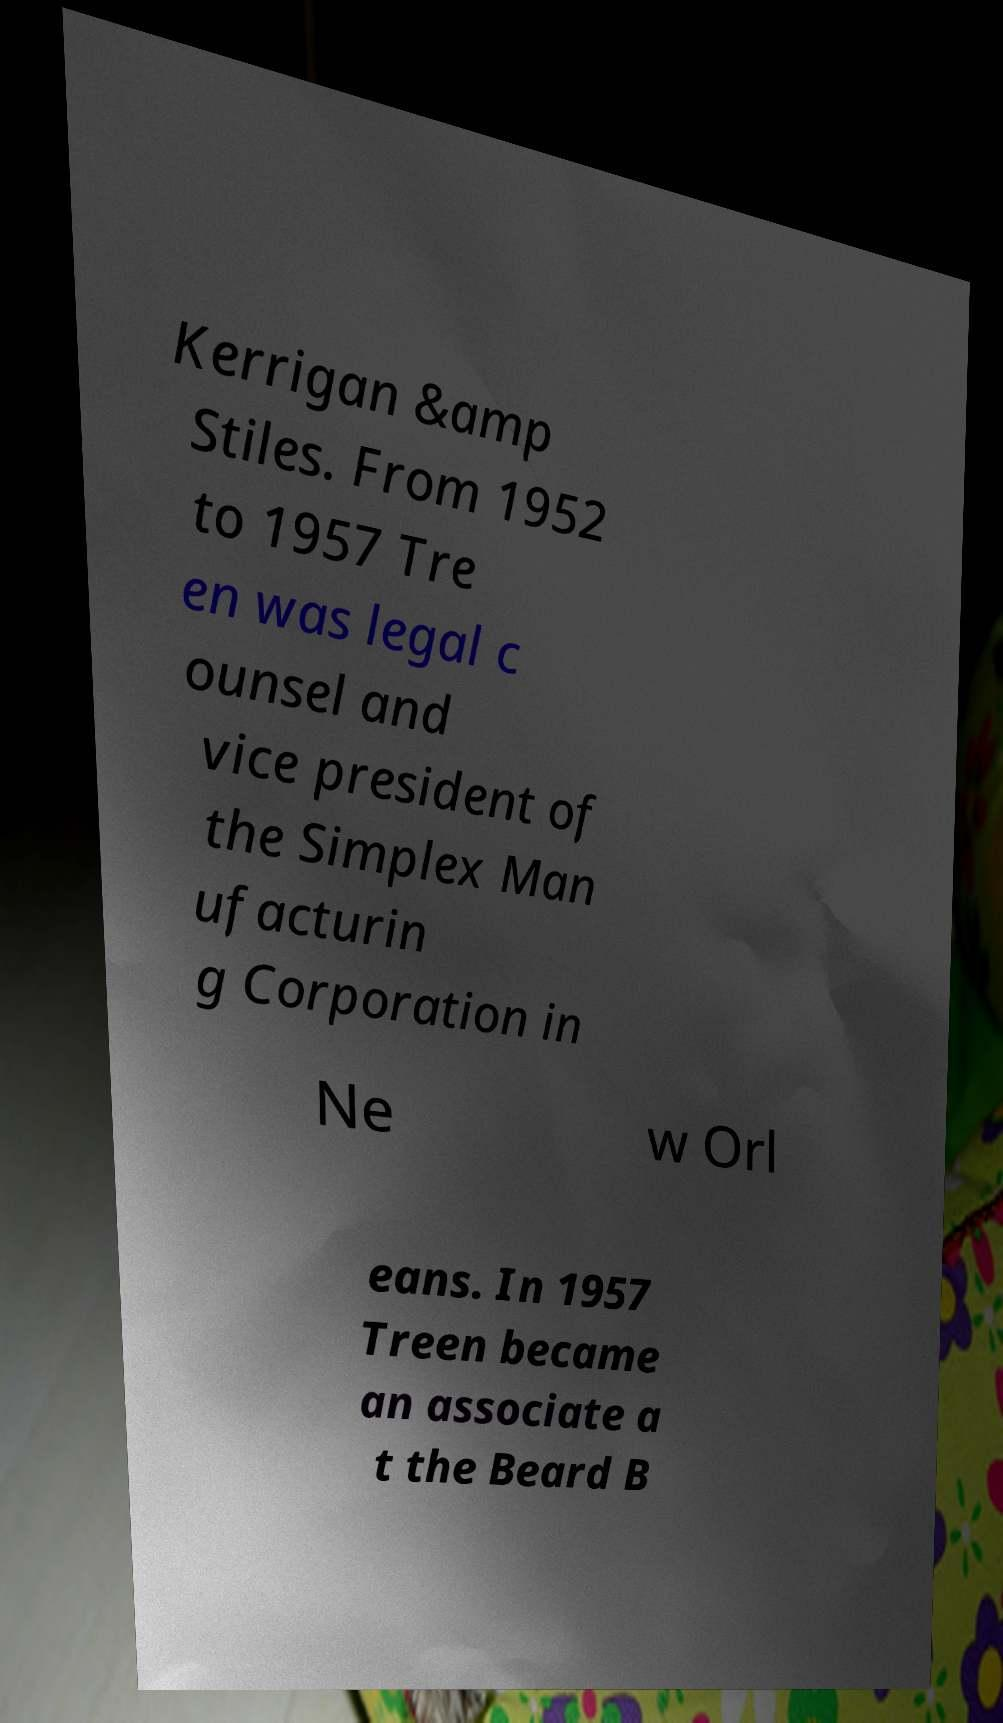For documentation purposes, I need the text within this image transcribed. Could you provide that? Kerrigan &amp Stiles. From 1952 to 1957 Tre en was legal c ounsel and vice president of the Simplex Man ufacturin g Corporation in Ne w Orl eans. In 1957 Treen became an associate a t the Beard B 